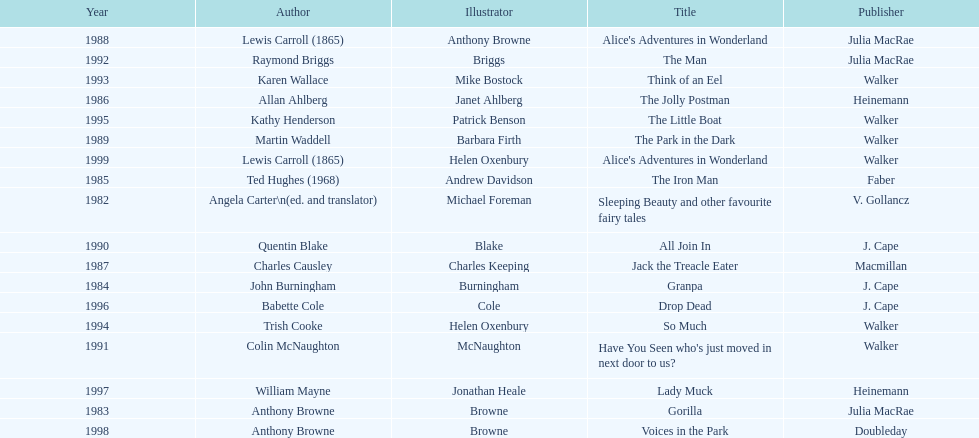How many times has anthony browne won an kurt maschler award for illustration? 3. 